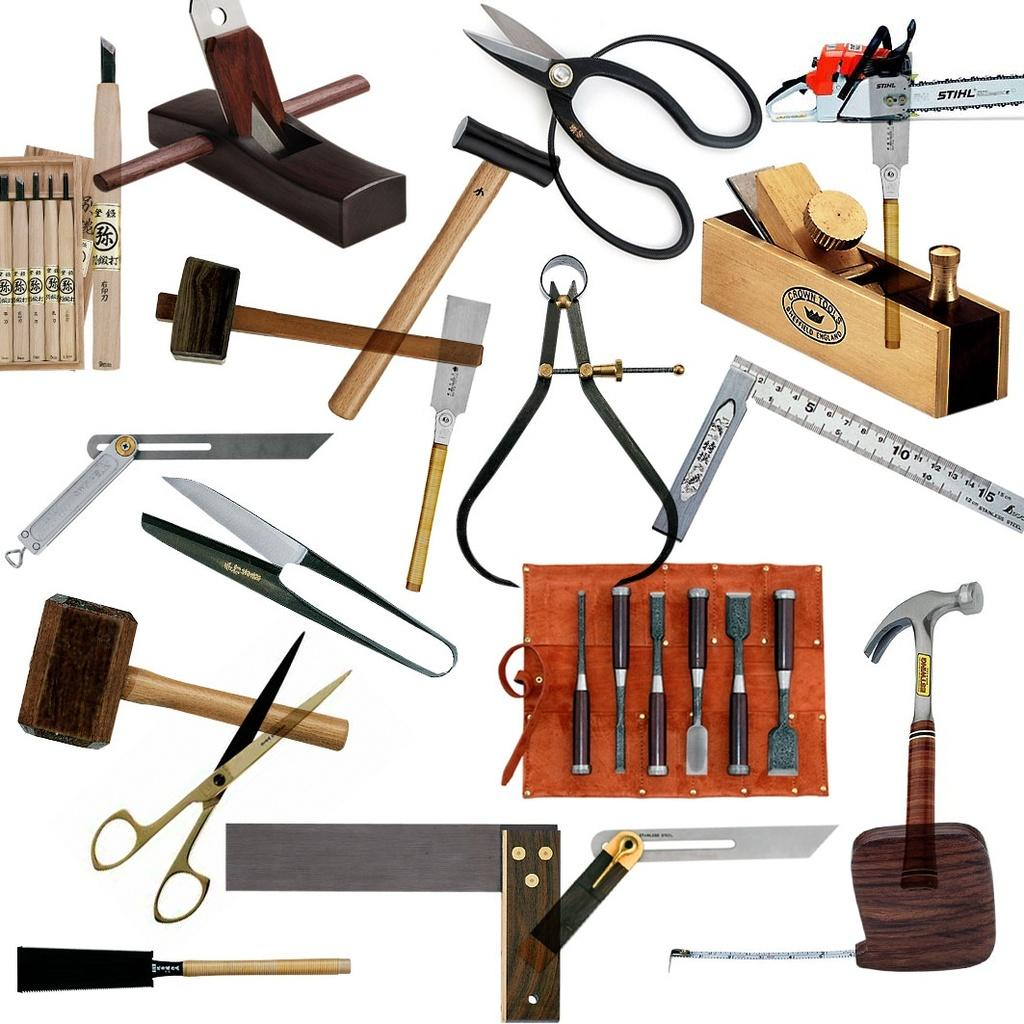What type of tools are present in the image? There are hammers, a claw hammer, a scissor, and a cutter in the image. What other object can be seen in the image? There is a scale in the image. How are the tools stored or organized in the image? The tools are stored in a box in the image. Can you describe any other unspecified objects in the image? There are other unspecified objects in the image, but their details are not provided. How much money is on the scale in the image? There is no money present on the scale in the image; only a scale is visible. What type of spiders can be seen weaving lace in the image? There are no spiders or lace present in the image. 